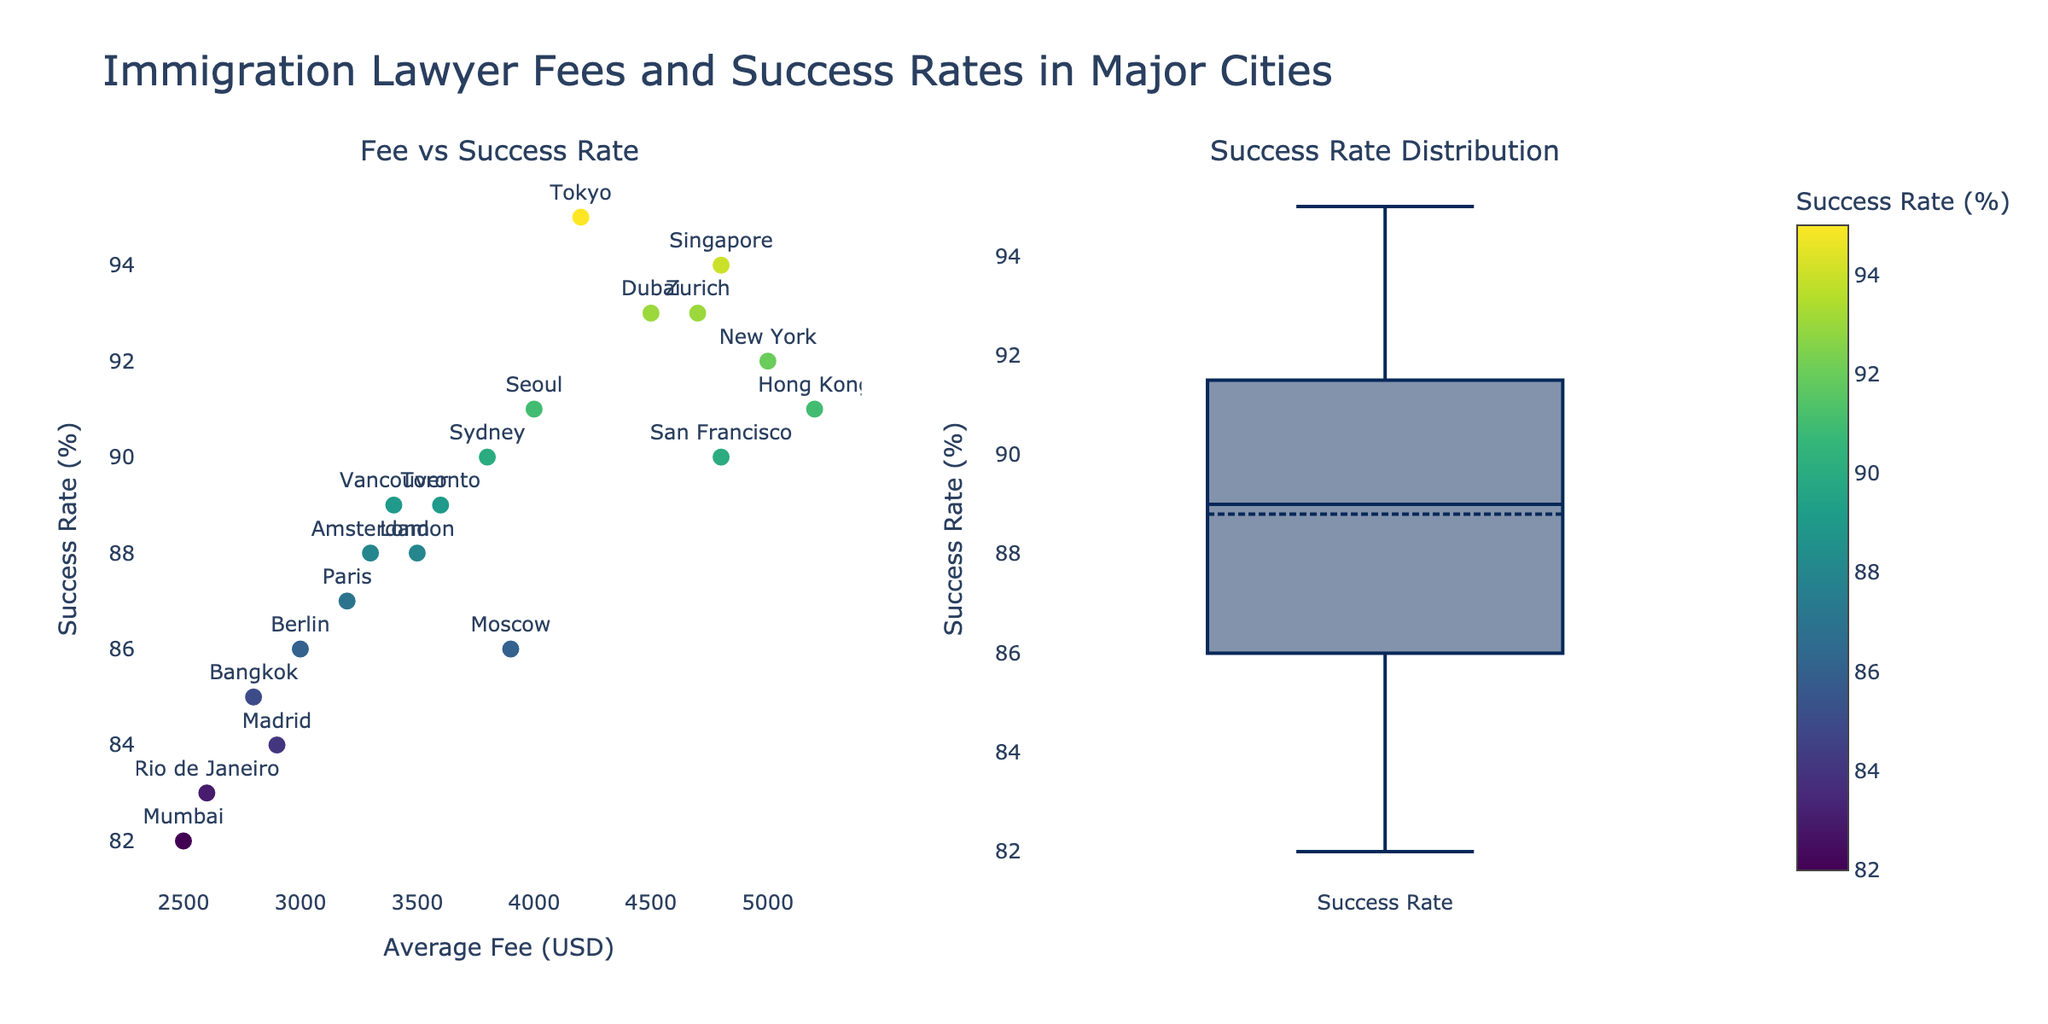What is the title of the plot? The title is displayed at the top of the plot. It helps to understand what the figure represents.
Answer: "Immigration Lawyer Fees and Success Rates in Major Cities" What is the average fee for immigration lawyers in New York? Locate the point labeled "New York" on the scatter plot and check its x-coordinate.
Answer: $5000 Which city has the highest success rate? Look for the points with the highest y-coordinate in the scatter plot, indicating the success rate.
Answer: Tokyo Does Sydney have a higher or lower success rate compared to Toronto? Compare the y-coordinates of the points labeled "Sydney" and "Toronto" in the scatter plot.
Answer: Higher What is the success rate range shown in the scatter plot? Identify the minimum and maximum success rates by looking at the y-axis values for all points.
Answer: 82% to 95% How many cities have a success rate of 90% or higher? Count the points on the scatter plot with a y-coordinate of 90% or above.
Answer: 10 Which city has the lowest average fee and what is it? Identify the point with the lowest x-coordinate in the scatter plot and check its corresponding label and value.
Answer: Mumbai, $2500 Is there a visible correlation between immigration lawyer fees and success rates? Observe the scatter plot to see if higher fees are generally associated with higher success rates.
Answer: Yes, a positive correlation Which cities have a success rate of exactly 88%? Identify the points with a y-coordinate of 88% and check their labels.
Answer: London and Amsterdam What is the interquartile range (IQR) for the success rates? Review the box plot to find the 25th and 75th percentiles and subtract the 25th percentile from the 75th percentile.
Answer: 88% - 85% = 3% 